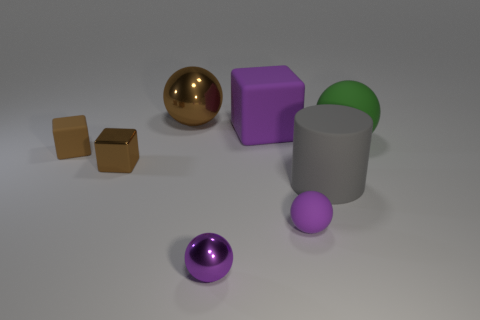The small ball that is left of the purple ball behind the metal ball that is in front of the brown metal block is what color?
Give a very brief answer. Purple. Does the brown cube that is on the left side of the brown metallic block have the same material as the large green object that is right of the large brown metal ball?
Provide a short and direct response. Yes. The purple rubber object in front of the large green matte thing has what shape?
Give a very brief answer. Sphere. What number of objects are either tiny metal spheres or brown objects that are in front of the brown rubber block?
Your response must be concise. 2. Does the big gray thing have the same material as the big brown ball?
Make the answer very short. No. Is the number of big green things left of the purple cube the same as the number of big gray matte cylinders that are behind the large gray object?
Give a very brief answer. Yes. How many blocks are left of the big gray matte thing?
Your answer should be very brief. 3. How many objects are either purple matte things or small red cylinders?
Your answer should be compact. 2. How many metallic spheres have the same size as the green rubber object?
Your answer should be compact. 1. The big brown metal object that is behind the small matte thing that is behind the big gray rubber object is what shape?
Give a very brief answer. Sphere. 